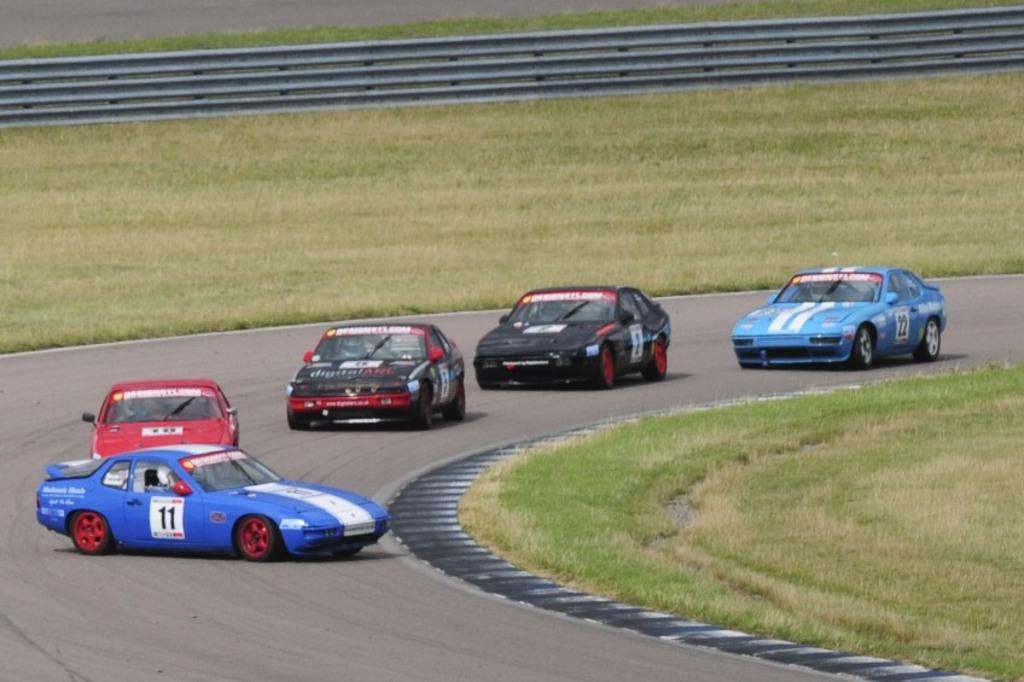What can be seen in the center of the image? There are cars on the road in the image. Where is the grass located in the image? There is grass on the right side of the image, and there is also grass in the background of the image. What is present in the background of the image? There is fencing in the background of the image. What type of behavior can be observed in the wilderness in the image? There is no wilderness present in the image; it features cars on a road and grass on the right side. What key is used to unlock the car doors in the image? There is no key visible in the image, and the cars' doors are not shown to be locked or unlocked. 